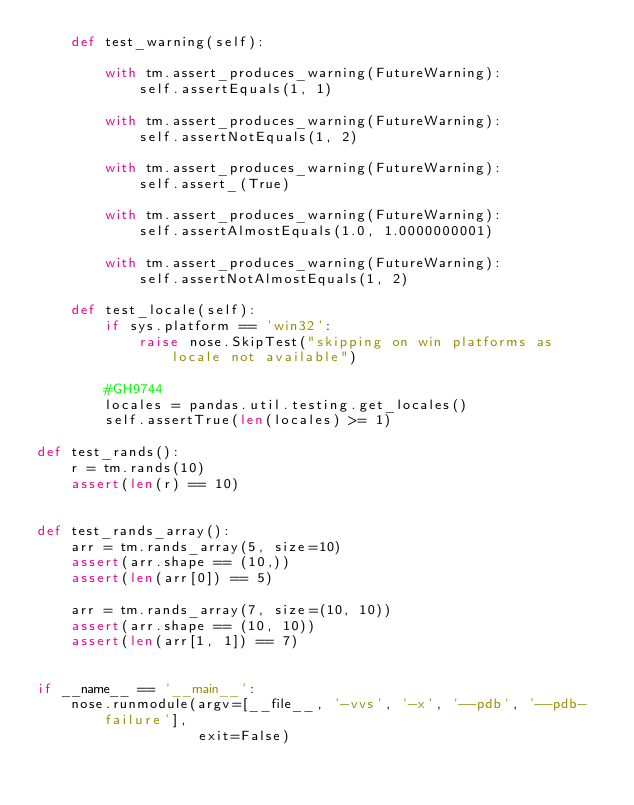Convert code to text. <code><loc_0><loc_0><loc_500><loc_500><_Python_>    def test_warning(self):

        with tm.assert_produces_warning(FutureWarning):
            self.assertEquals(1, 1)

        with tm.assert_produces_warning(FutureWarning):
            self.assertNotEquals(1, 2)

        with tm.assert_produces_warning(FutureWarning):
            self.assert_(True)

        with tm.assert_produces_warning(FutureWarning):
            self.assertAlmostEquals(1.0, 1.0000000001)

        with tm.assert_produces_warning(FutureWarning):
            self.assertNotAlmostEquals(1, 2)

    def test_locale(self):
        if sys.platform == 'win32':
            raise nose.SkipTest("skipping on win platforms as locale not available")

        #GH9744
        locales = pandas.util.testing.get_locales()
        self.assertTrue(len(locales) >= 1)

def test_rands():
    r = tm.rands(10)
    assert(len(r) == 10)


def test_rands_array():
    arr = tm.rands_array(5, size=10)
    assert(arr.shape == (10,))
    assert(len(arr[0]) == 5)

    arr = tm.rands_array(7, size=(10, 10))
    assert(arr.shape == (10, 10))
    assert(len(arr[1, 1]) == 7)


if __name__ == '__main__':
    nose.runmodule(argv=[__file__, '-vvs', '-x', '--pdb', '--pdb-failure'],
                   exit=False)
</code> 